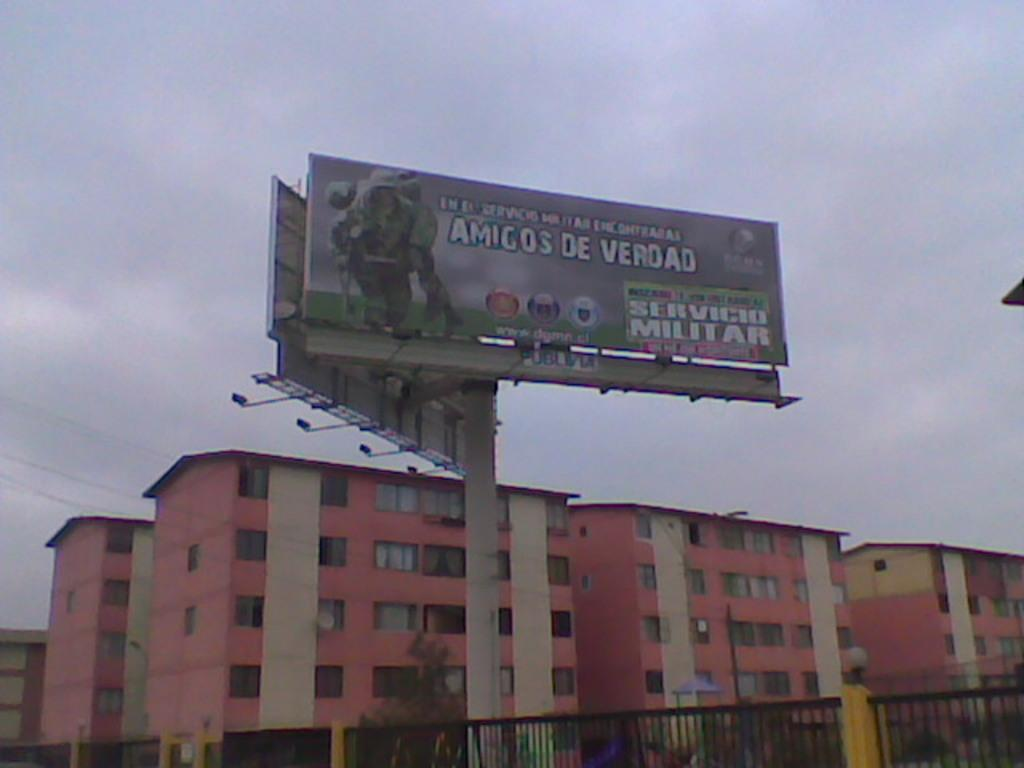<image>
Create a compact narrative representing the image presented. A billboard for the miliary is posted beside a pink building. 